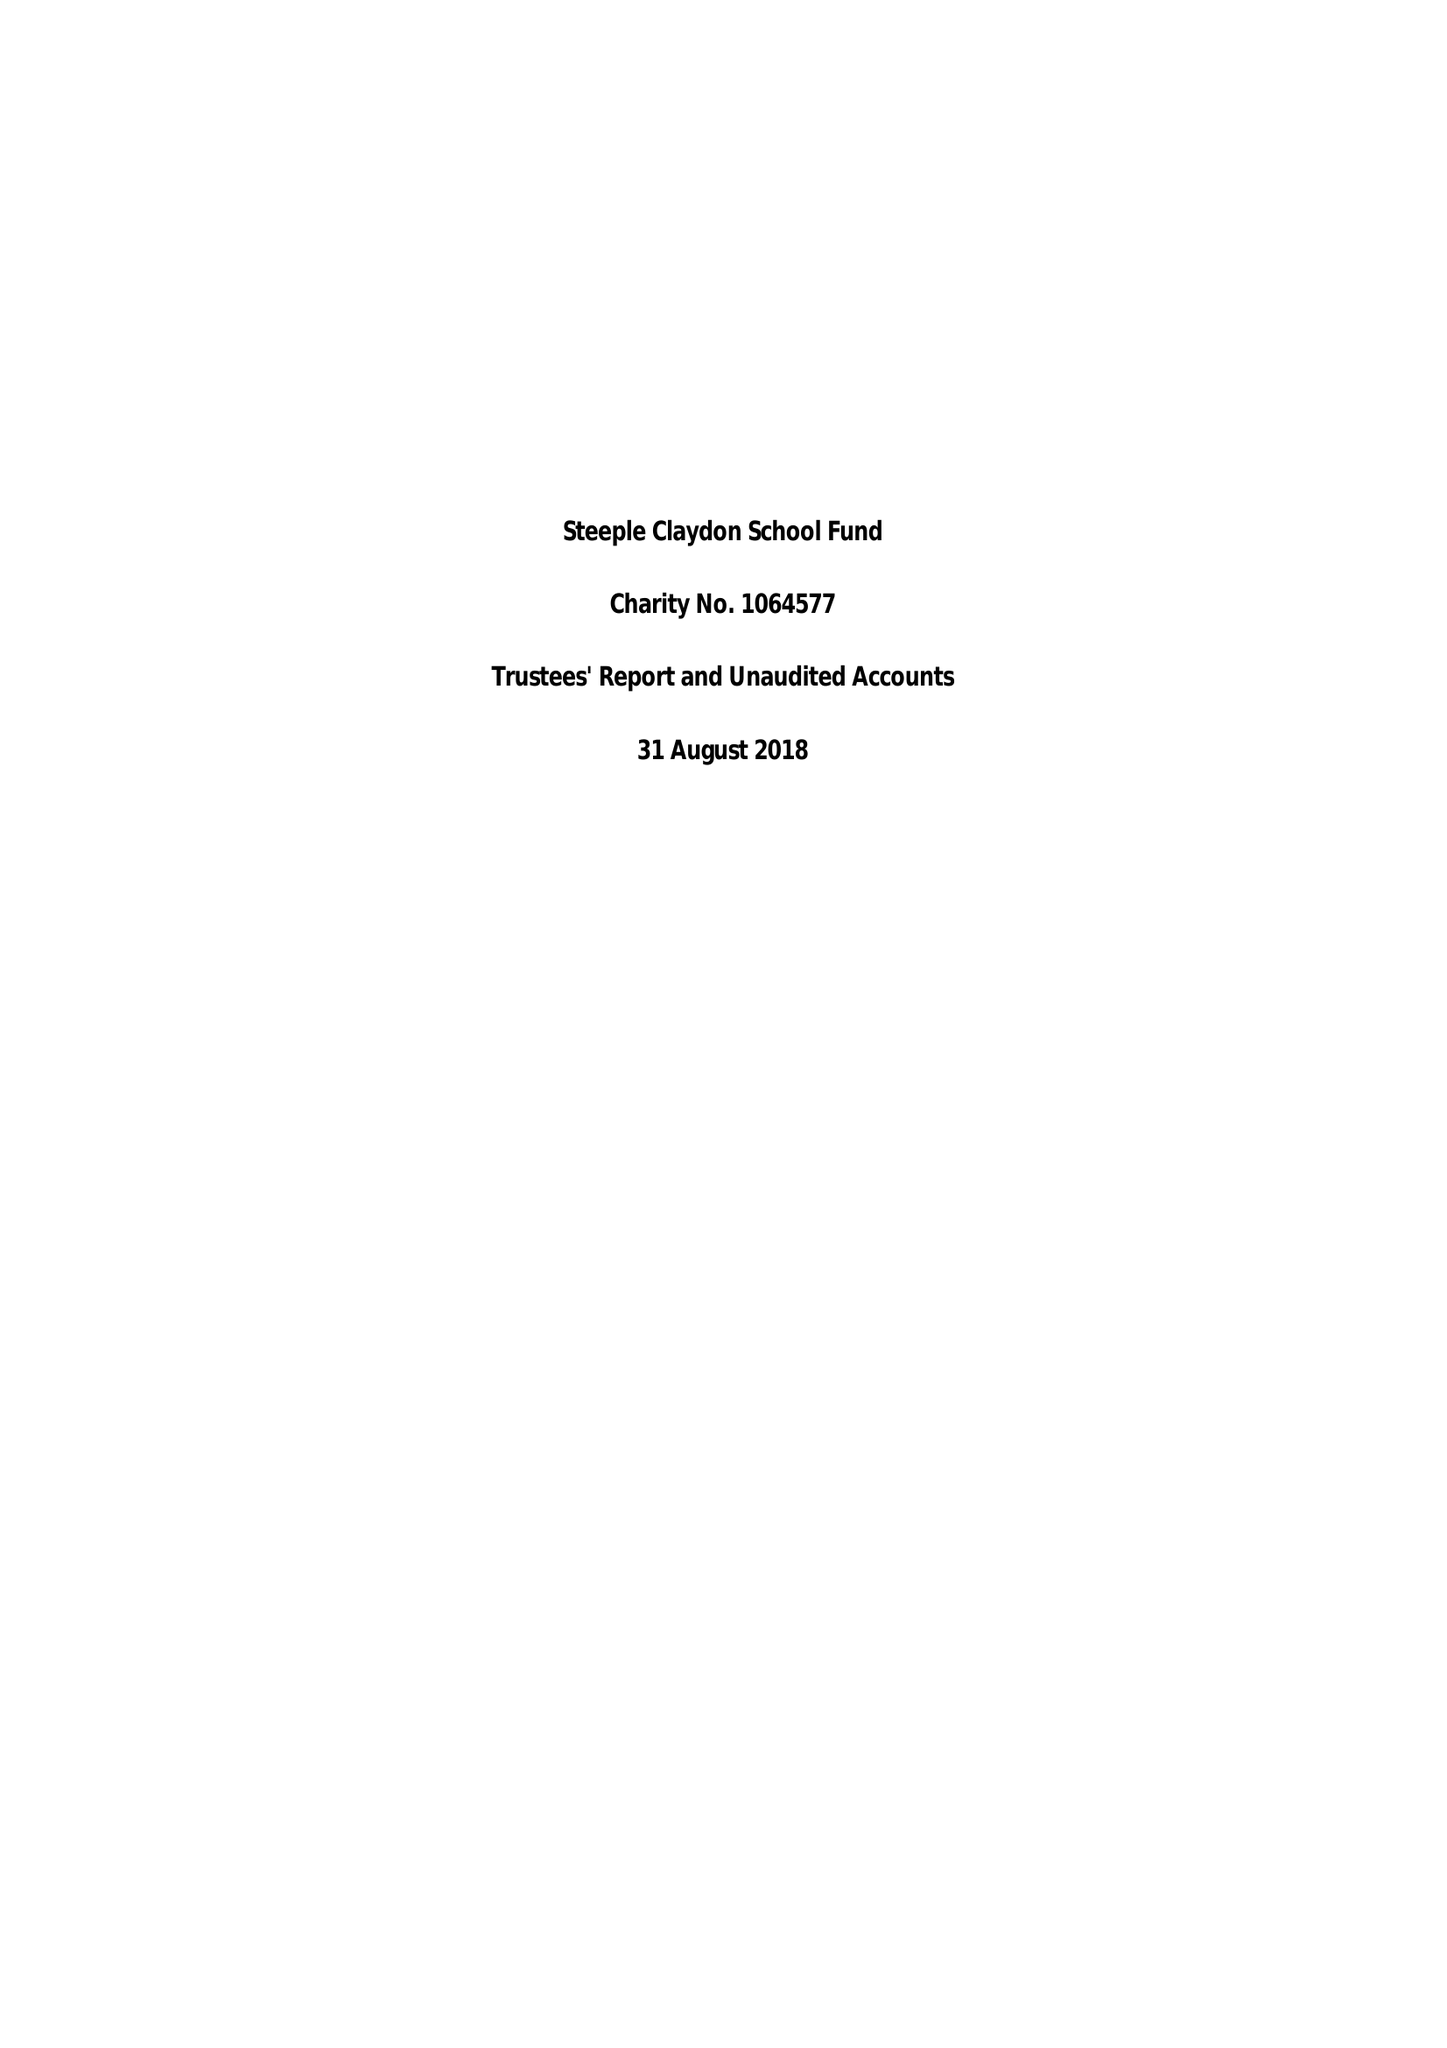What is the value for the address__postcode?
Answer the question using a single word or phrase. MK18 2PA 